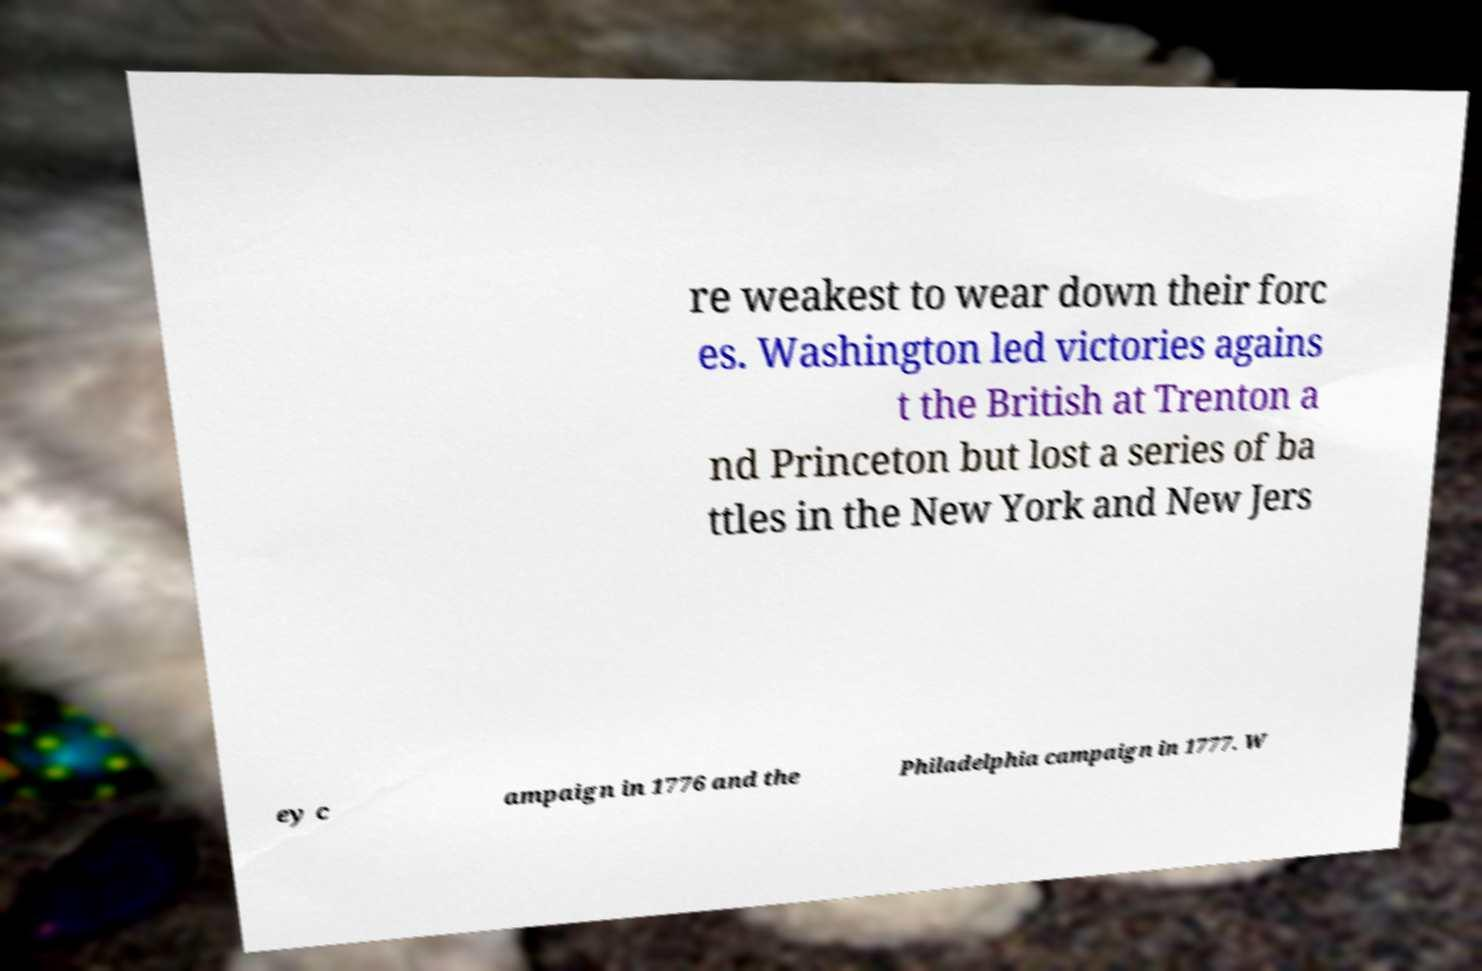For documentation purposes, I need the text within this image transcribed. Could you provide that? re weakest to wear down their forc es. Washington led victories agains t the British at Trenton a nd Princeton but lost a series of ba ttles in the New York and New Jers ey c ampaign in 1776 and the Philadelphia campaign in 1777. W 